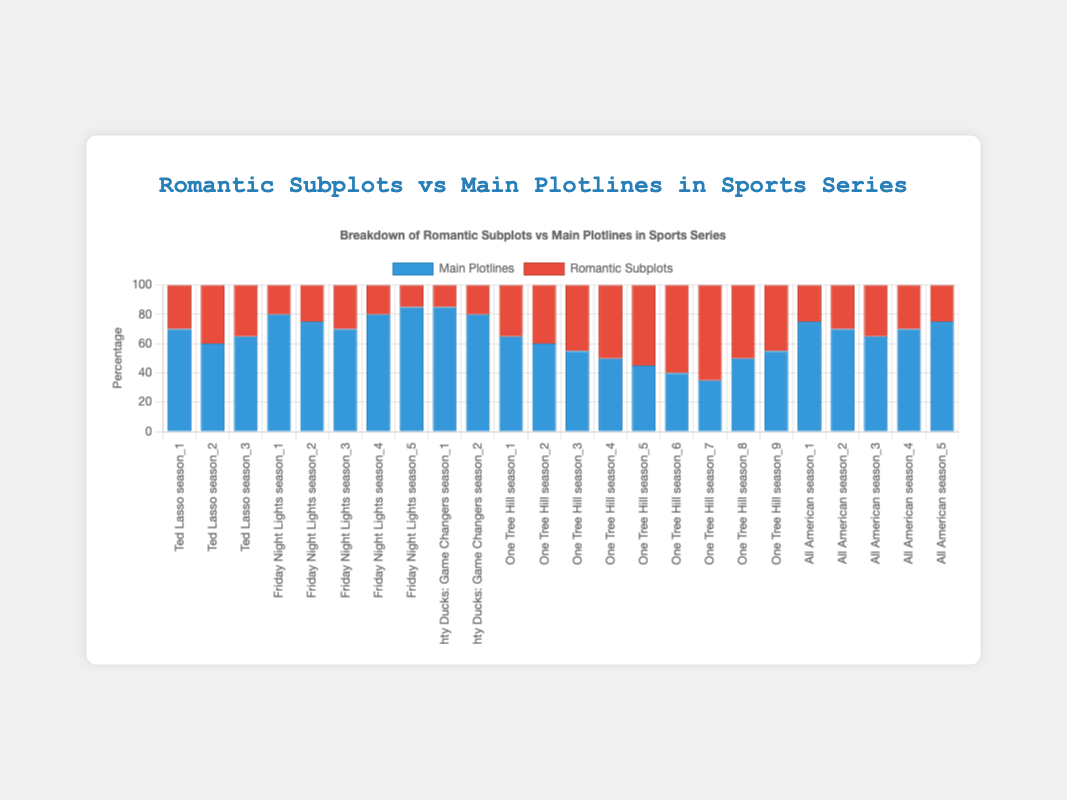Which series has the lowest percentage of romantic subplots in any season? By examining the figure, you can see that "Friday Night Lights" Season 5 has the lowest percentage of romantic subplots at 15%.
Answer: Friday Night Lights How does the percentage of romantic subplots in Season 3 of "Ted Lasso" compare to Season 3 of "All American"? Look at the height of the "romantic subplots" bars for Season 3 of both "Ted Lasso" and "All American." "Ted Lasso" has 35%, while "All American" has 35% as well, making their percentages equal.
Answer: Equal What is the total percentage for main plotlines and romantic subplots combined in Season 2 of "The Mighty Ducks: Game Changers"? Add the percentage of main plotlines and romantic subplots for Season 2 of "The Mighty Ducks: Game Changers": 80% (main plotlines) + 20% (romantic subplots) = 100%.
Answer: 100% Which series shows a significant increase in the percentage of romantic subplots from one season to the next? Review the figure for a noticeable increase in bar height from one season to the next. "One Tree Hill" shows a significant increase from Season 6 (60%) to Season 7 (65%).
Answer: One Tree Hill Compare the average percentage of main plotlines in "Friday Night Lights" over all seasons with "Ted Lasso." Calculate the average for each series:
Friday Night Lights: (80 + 75 + 70 + 80 + 85) / 5 = 78
Ted Lasso: (70 + 60 + 65) / 3 = 65
"Friday Night Lights" has a higher average percentage of main plotlines.
Answer: Friday Night Lights Which series features the highest overall percentage for main plotlines across all seasons? Look for the series with the tallest main plotlines bars consistently. "The Mighty Ducks: Game Changers" has the highest percentages consistently: Season 1 (85%) and Season 2 (80%).
Answer: The Mighty Ducks: Game Changers What is the trend in romantic subplots for "All American" across its seasons? By observing the figure, it can be seen that the percentage starts at 25% in Season 1, increases to 30% in Season 2, rises to 35% in Season 3, then drops back to 30% in Season 4 and decreases further to 25% in Season 5.
Answer: Increasing until Season 3, then decreasing How does the percentage of main plotlines in "Season 1" for "One Tree Hill" compare visually to Season 1 of "Ted Lasso"? Visually compare the height of the "main plotlines" bars for Season 1 of both series. "One Tree Hill" stands at 65% and "Ted Lasso" is at 70%, so "Ted Lasso" has a slightly higher percentage.
Answer: Ted Lasso In which series does the percentage of romantic subplots never exceed the percentage of main plotlines in any season? Observe the height of the "romantic subplots" versus "main plotlines" bars. In "Friday Night Lights," the bars for romantic subplots never exceed those for main plotlines in any season.
Answer: Friday Night Lights 